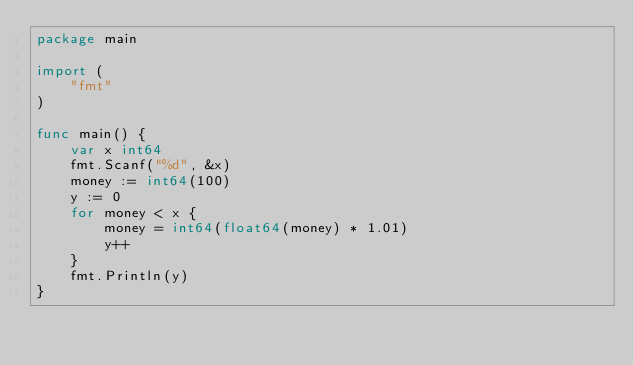<code> <loc_0><loc_0><loc_500><loc_500><_Go_>package main

import (
	"fmt"
)

func main() {
	var x int64
	fmt.Scanf("%d", &x)
	money := int64(100)
	y := 0
	for money < x {
		money = int64(float64(money) * 1.01)
		y++
	}
	fmt.Println(y)
}
</code> 